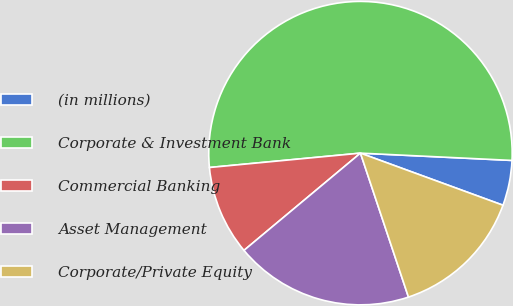Convert chart to OTSL. <chart><loc_0><loc_0><loc_500><loc_500><pie_chart><fcel>(in millions)<fcel>Corporate & Investment Bank<fcel>Commercial Banking<fcel>Asset Management<fcel>Corporate/Private Equity<nl><fcel>4.81%<fcel>52.27%<fcel>9.56%<fcel>19.05%<fcel>14.3%<nl></chart> 